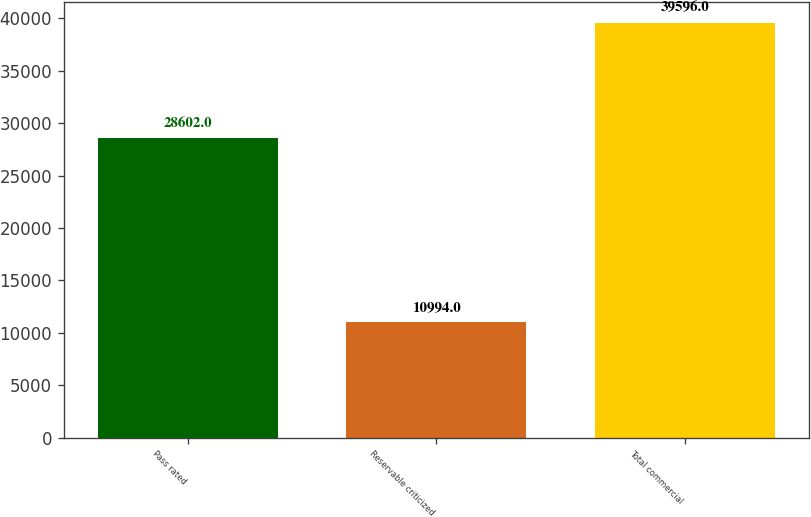Convert chart to OTSL. <chart><loc_0><loc_0><loc_500><loc_500><bar_chart><fcel>Pass rated<fcel>Reservable criticized<fcel>Total commercial<nl><fcel>28602<fcel>10994<fcel>39596<nl></chart> 